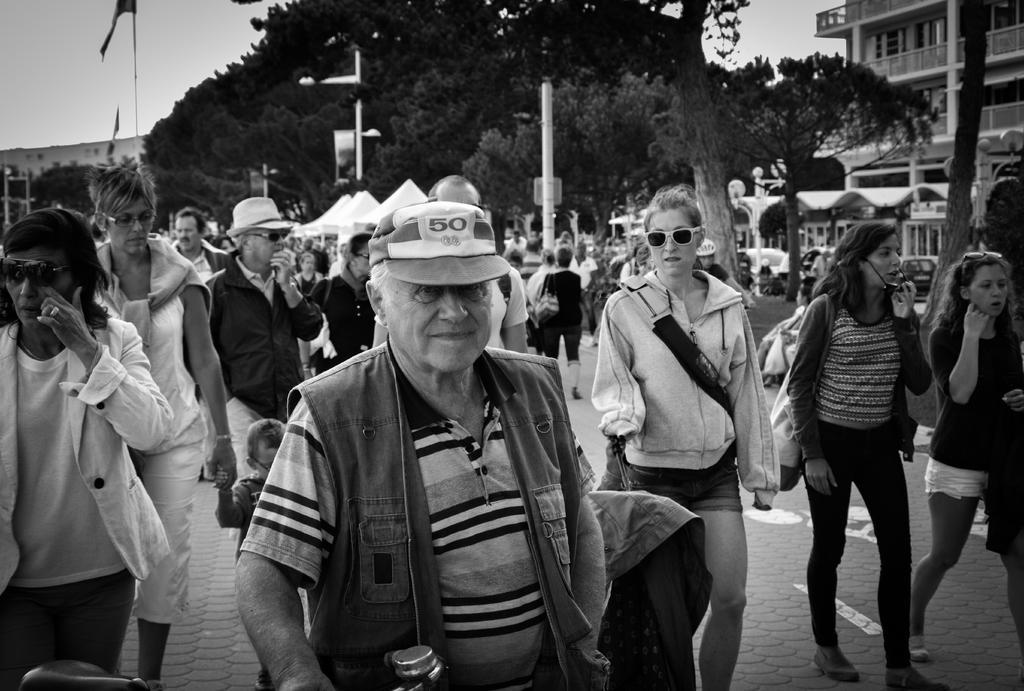In one or two sentences, can you explain what this image depicts? In this picture I can see number of people who are on the path. In the background I can see the poles, trees, few buildings, cars and the sky. I see that this is a black and white picture. 